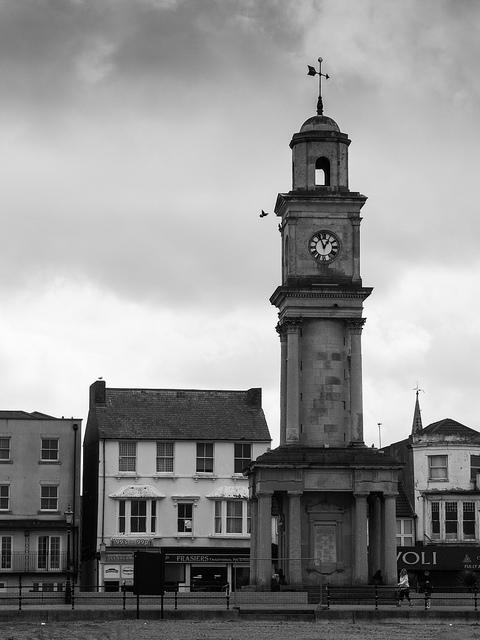What is the name for the cross shaped structure on top of the tower? weather vane 